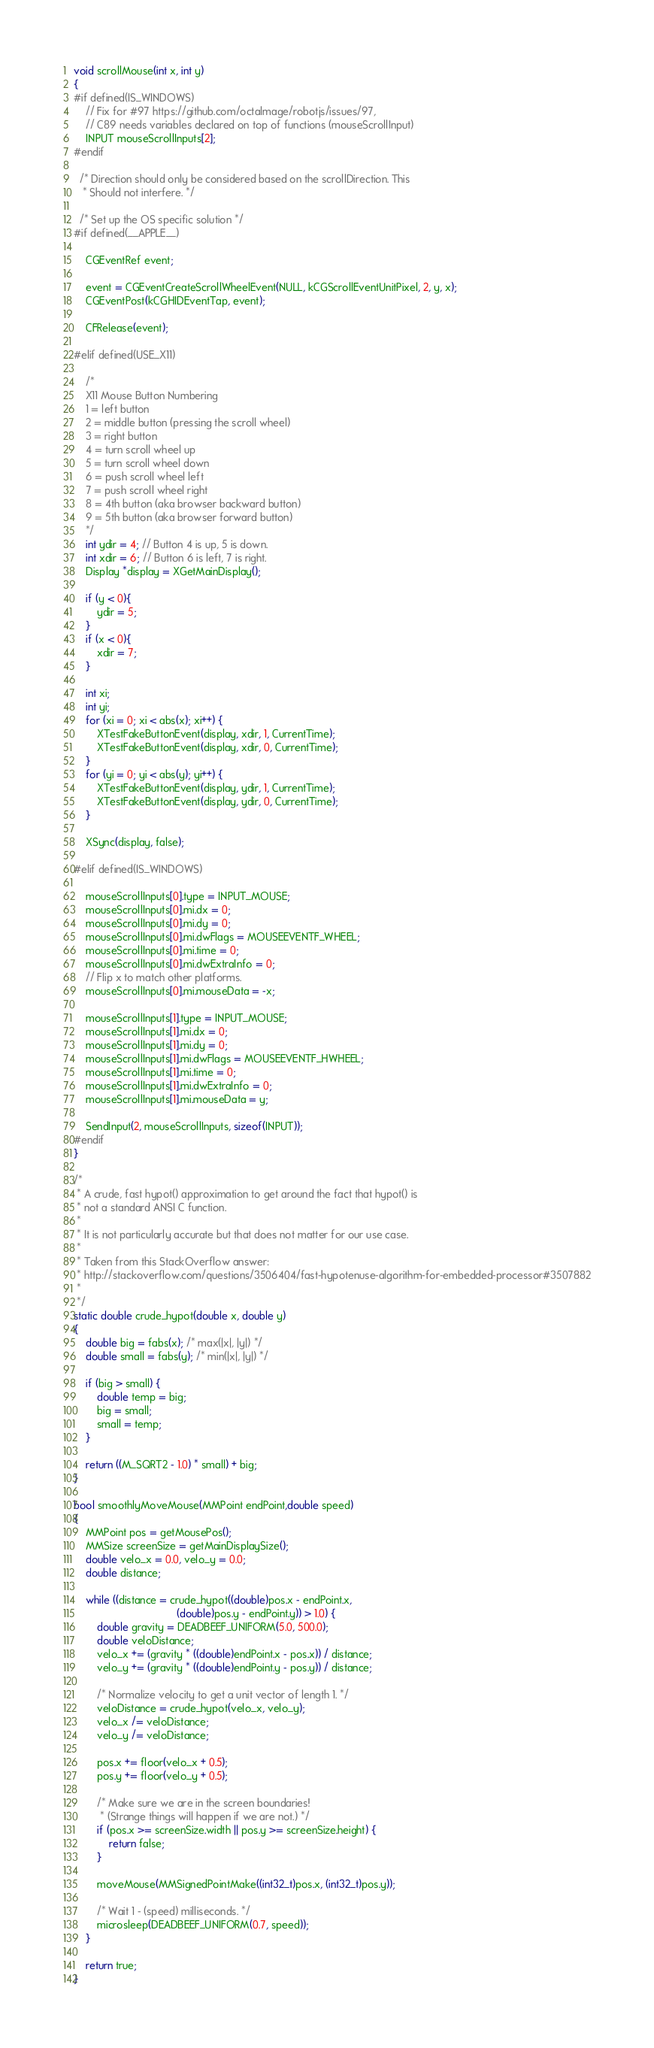<code> <loc_0><loc_0><loc_500><loc_500><_C_>void scrollMouse(int x, int y)
{
#if defined(IS_WINDOWS)
	// Fix for #97 https://github.com/octalmage/robotjs/issues/97,
	// C89 needs variables declared on top of functions (mouseScrollInput)
	INPUT mouseScrollInputs[2];
#endif

  /* Direction should only be considered based on the scrollDirection. This
   * Should not interfere. */

  /* Set up the OS specific solution */
#if defined(__APPLE__)

	CGEventRef event;

	event = CGEventCreateScrollWheelEvent(NULL, kCGScrollEventUnitPixel, 2, y, x);
	CGEventPost(kCGHIDEventTap, event);

	CFRelease(event);

#elif defined(USE_X11)

	/*
	X11 Mouse Button Numbering
	1 = left button
	2 = middle button (pressing the scroll wheel)
	3 = right button
	4 = turn scroll wheel up
	5 = turn scroll wheel down
	6 = push scroll wheel left
	7 = push scroll wheel right
	8 = 4th button (aka browser backward button)
	9 = 5th button (aka browser forward button)
	*/
	int ydir = 4; // Button 4 is up, 5 is down.
	int xdir = 6; // Button 6 is left, 7 is right.
	Display *display = XGetMainDisplay();

	if (y < 0){
		ydir = 5;
	}
	if (x < 0){
		xdir = 7;
	}

	int xi;
	int yi;
	for (xi = 0; xi < abs(x); xi++) {
		XTestFakeButtonEvent(display, xdir, 1, CurrentTime);
		XTestFakeButtonEvent(display, xdir, 0, CurrentTime);
	}
	for (yi = 0; yi < abs(y); yi++) {
		XTestFakeButtonEvent(display, ydir, 1, CurrentTime);
		XTestFakeButtonEvent(display, ydir, 0, CurrentTime);
	}

	XSync(display, false);

#elif defined(IS_WINDOWS)

	mouseScrollInputs[0].type = INPUT_MOUSE;
	mouseScrollInputs[0].mi.dx = 0;
	mouseScrollInputs[0].mi.dy = 0;
	mouseScrollInputs[0].mi.dwFlags = MOUSEEVENTF_WHEEL;
	mouseScrollInputs[0].mi.time = 0;
	mouseScrollInputs[0].mi.dwExtraInfo = 0;
	// Flip x to match other platforms.
	mouseScrollInputs[0].mi.mouseData = -x;

	mouseScrollInputs[1].type = INPUT_MOUSE;
	mouseScrollInputs[1].mi.dx = 0;
	mouseScrollInputs[1].mi.dy = 0;
	mouseScrollInputs[1].mi.dwFlags = MOUSEEVENTF_HWHEEL;
	mouseScrollInputs[1].mi.time = 0;
	mouseScrollInputs[1].mi.dwExtraInfo = 0;
	mouseScrollInputs[1].mi.mouseData = y;

	SendInput(2, mouseScrollInputs, sizeof(INPUT));
#endif
}

/*
 * A crude, fast hypot() approximation to get around the fact that hypot() is
 * not a standard ANSI C function.
 *
 * It is not particularly accurate but that does not matter for our use case.
 *
 * Taken from this StackOverflow answer:
 * http://stackoverflow.com/questions/3506404/fast-hypotenuse-algorithm-for-embedded-processor#3507882
 *
 */
static double crude_hypot(double x, double y)
{
	double big = fabs(x); /* max(|x|, |y|) */
	double small = fabs(y); /* min(|x|, |y|) */

	if (big > small) {
		double temp = big;
		big = small;
		small = temp;
	}

	return ((M_SQRT2 - 1.0) * small) + big;
}

bool smoothlyMoveMouse(MMPoint endPoint,double speed)
{
	MMPoint pos = getMousePos();
	MMSize screenSize = getMainDisplaySize();
	double velo_x = 0.0, velo_y = 0.0;
	double distance;

	while ((distance = crude_hypot((double)pos.x - endPoint.x,
	                               (double)pos.y - endPoint.y)) > 1.0) {
		double gravity = DEADBEEF_UNIFORM(5.0, 500.0);
		double veloDistance;
		velo_x += (gravity * ((double)endPoint.x - pos.x)) / distance;
		velo_y += (gravity * ((double)endPoint.y - pos.y)) / distance;

		/* Normalize velocity to get a unit vector of length 1. */
		veloDistance = crude_hypot(velo_x, velo_y);
		velo_x /= veloDistance;
		velo_y /= veloDistance;

		pos.x += floor(velo_x + 0.5);
		pos.y += floor(velo_y + 0.5);

		/* Make sure we are in the screen boundaries!
		 * (Strange things will happen if we are not.) */
		if (pos.x >= screenSize.width || pos.y >= screenSize.height) {
			return false;
		}

		moveMouse(MMSignedPointMake((int32_t)pos.x, (int32_t)pos.y));

		/* Wait 1 - (speed) milliseconds. */
		microsleep(DEADBEEF_UNIFORM(0.7, speed));
	}

	return true;
}
</code> 